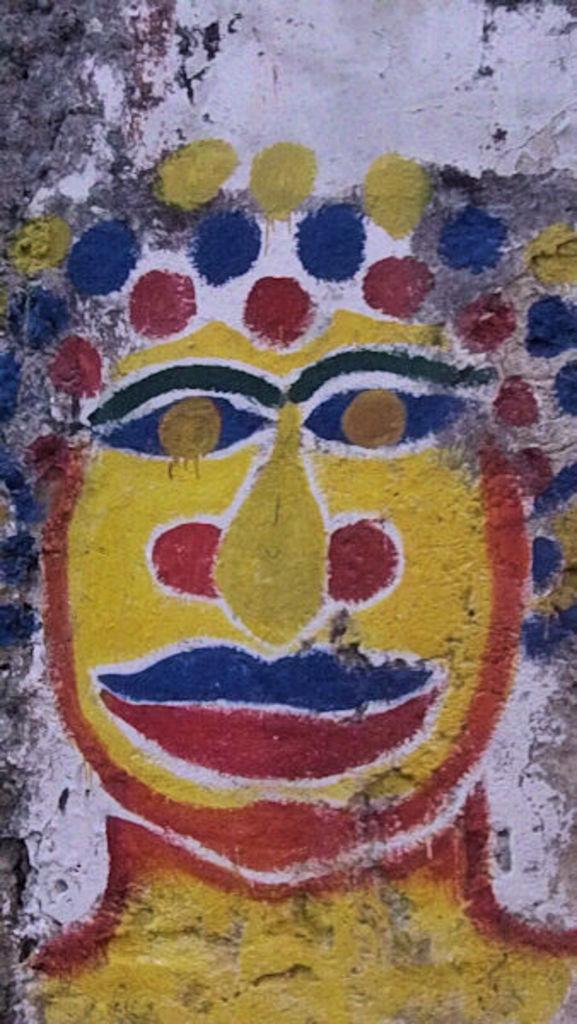What is featured on the wall in the image? There is a depiction on the wall in the image. What type of playground equipment can be seen in the image? There is no playground equipment present in the image; it only features a depiction on the wall. 